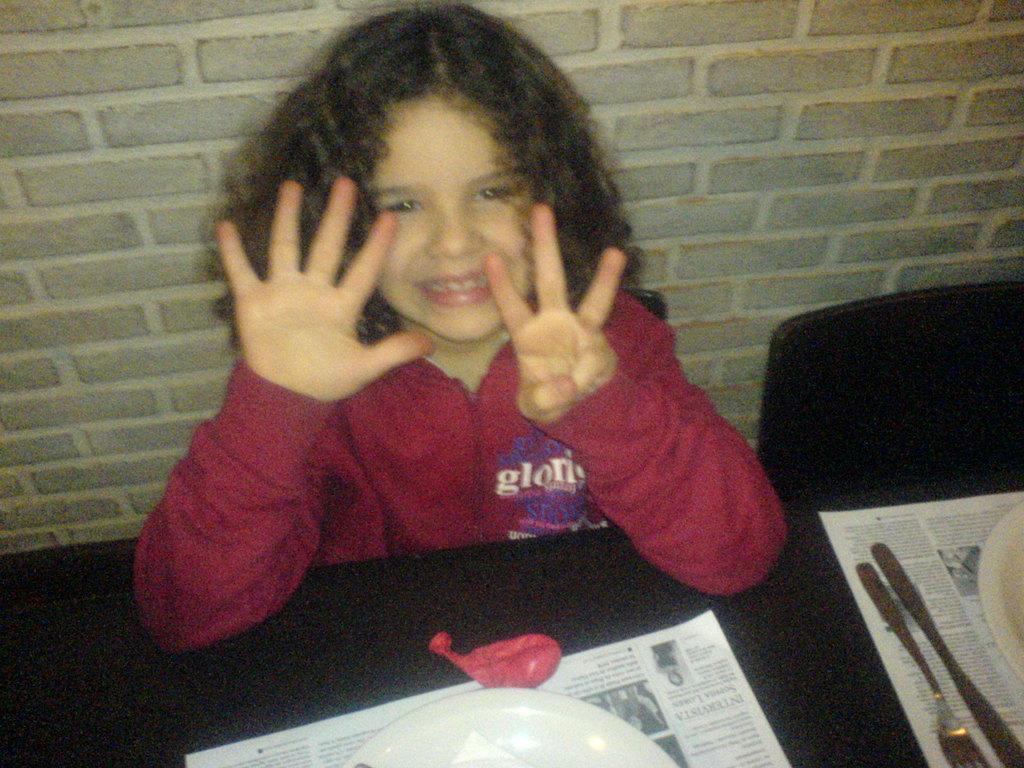Describe this image in one or two sentences. In this image I see a girl who is wearing red top and I see that she is sitting on a chair and I see that she is smiling and I see a table in front of her on which there are white plates, a fork, a knife and 2 papers below the plates and I see an empty chair. 